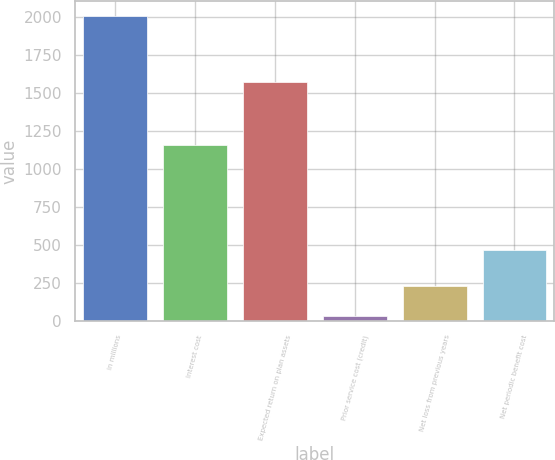Convert chart to OTSL. <chart><loc_0><loc_0><loc_500><loc_500><bar_chart><fcel>in millions<fcel>Interest cost<fcel>Expected return on plan assets<fcel>Prior service cost (credit)<fcel>Net loss from previous years<fcel>Net periodic benefit cost<nl><fcel>2006<fcel>1159<fcel>1572<fcel>35<fcel>232.1<fcel>468<nl></chart> 